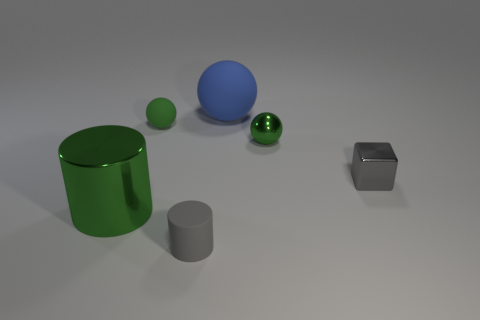Subtract all tiny rubber spheres. How many spheres are left? 2 Subtract 1 cubes. How many cubes are left? 0 Add 2 tiny green matte cubes. How many objects exist? 8 Subtract all green cylinders. How many cylinders are left? 1 Add 5 purple metallic things. How many purple metallic things exist? 5 Subtract 1 gray cubes. How many objects are left? 5 Subtract all cylinders. How many objects are left? 4 Subtract all cyan balls. Subtract all blue cylinders. How many balls are left? 3 Subtract all brown balls. How many green cylinders are left? 1 Subtract all tiny cyan rubber spheres. Subtract all big cylinders. How many objects are left? 5 